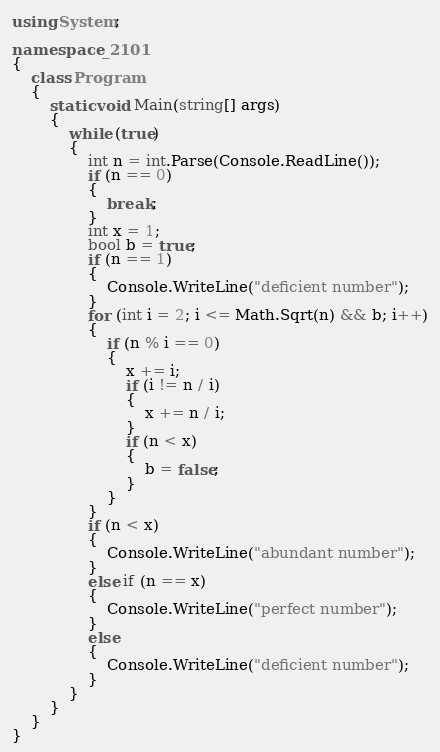<code> <loc_0><loc_0><loc_500><loc_500><_C#_>using System;

namespace _2101
{
    class Program
    {
        static void Main(string[] args)
        {
            while (true)
            {
                int n = int.Parse(Console.ReadLine());
                if (n == 0)
                {
                    break;
                }
                int x = 1;
                bool b = true;
                if (n == 1)
                {
                    Console.WriteLine("deficient number");
                }
                for (int i = 2; i <= Math.Sqrt(n) && b; i++)
                {
                    if (n % i == 0)
                    {
                        x += i;
                        if (i != n / i)
                        {
                            x += n / i;
                        }
                        if (n < x)
                        {
                            b = false;
                        }
                    }
                }
                if (n < x)
                {
                    Console.WriteLine("abundant number");
                }
                else if (n == x)
                {
                    Console.WriteLine("perfect number");
                }
                else
                {
                    Console.WriteLine("deficient number");
                }
            }
        }
    }
}</code> 